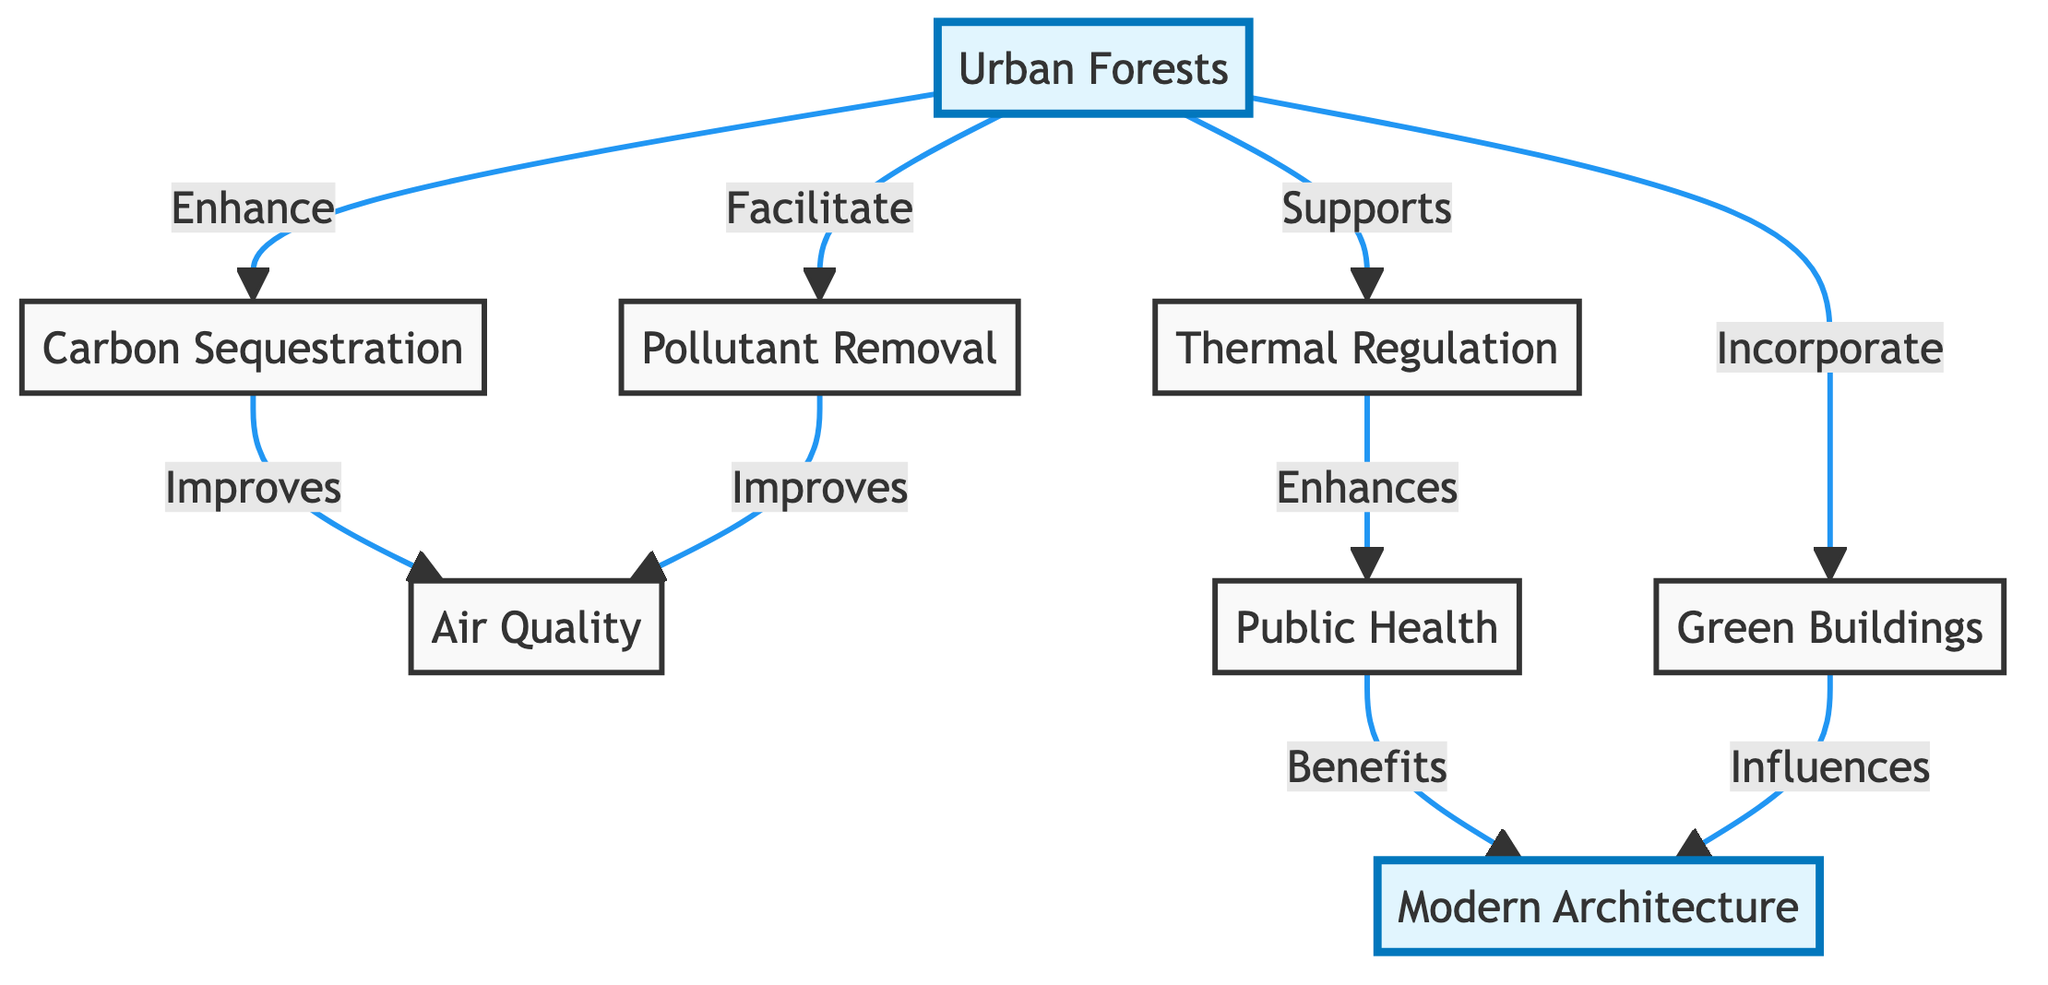What is the main impact of urban forests on air quality? The diagram indicates that urban forests enhance carbon sequestration and facilitate pollutant removal, both of which improve air quality.
Answer: Improve air quality How many effects of urban forests on air quality are listed in the diagram? The diagram shows three specific effects of urban forests on air quality: carbon sequestration, pollutant removal, and thermal regulation.
Answer: Three Which node directly benefits from public health in the diagram? The arrow indicates that public health enhances modern architecture, showing a direct benefit from public health.
Answer: Modern Architecture What type of buildings do urban forests incorporate according to the diagram? The diagram shows that urban forests incorporate green buildings, signifying the role of urban forests in modern architecture.
Answer: Green Buildings How do urban forests support public health? Urban forests, by supporting thermal regulation, contribute to enhanced public health. Therefore, thermal regulation is the key intermediary in this relationship.
Answer: Thermal Regulation Which two nodes are connected by the relationship "Facilitates"? The diagram indicates that urban forests facilitate pollutant removal, showing a direct relationship between these two nodes.
Answer: Pollutant Removal What is the relationship between green buildings and modern architecture? The diagram reveals that green buildings influence modern architecture, indicating a causal relationship whereby the design of green buildings impacts modern architectural practices.
Answer: Influences How does thermal regulation influence public health? According to the diagram, thermal regulation enhances public health, meaning that effective temperature regulation in urban areas contributes positively to community health outcomes.
Answer: Enhances What enhances air quality according to the diagram? The diagram describes that both carbon sequestration and pollutant removal enhance air quality, indicating dual pathways through which urban forests contribute to cleaner air.
Answer: Carbon Sequestration and Pollutant Removal 